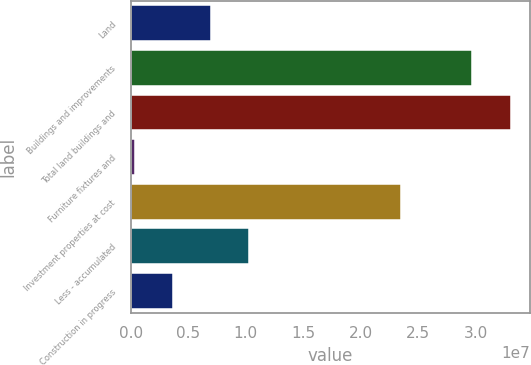Convert chart. <chart><loc_0><loc_0><loc_500><loc_500><bar_chart><fcel>Land<fcel>Buildings and improvements<fcel>Total land buildings and<fcel>Furniture fixtures and<fcel>Investment properties at cost<fcel>Less - accumulated<fcel>Construction in progress<nl><fcel>6.95682e+06<fcel>2.97152e+07<fcel>3.31329e+07<fcel>330239<fcel>2.35477e+07<fcel>1.02701e+07<fcel>3.64353e+06<nl></chart> 